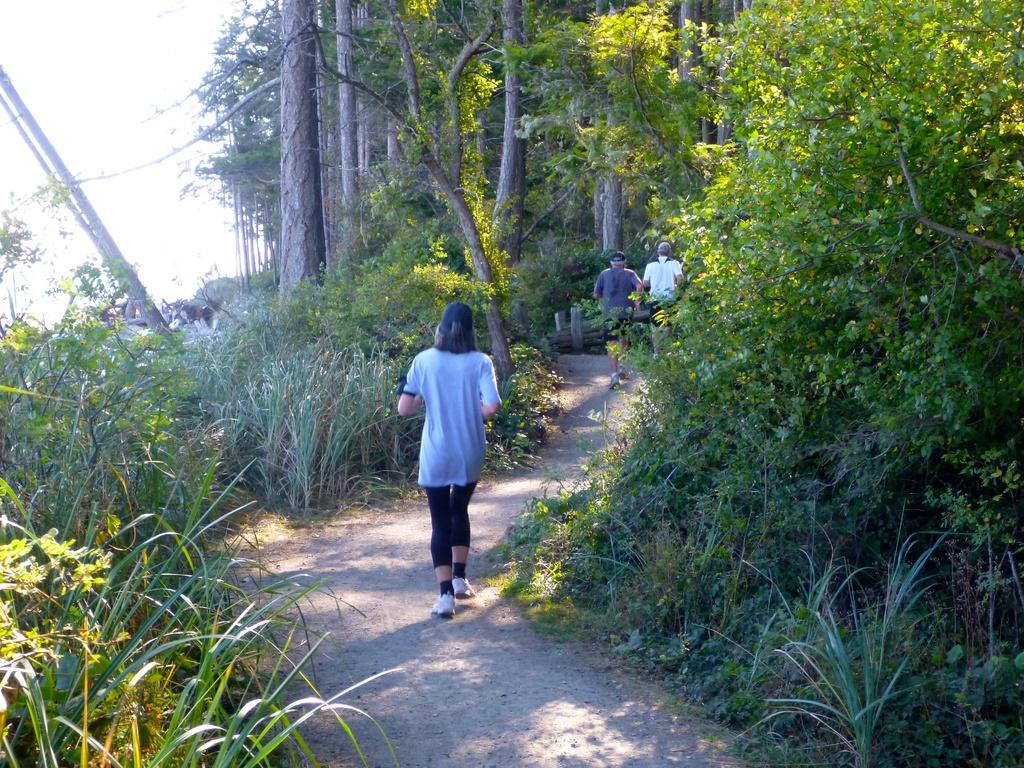What is the main feature of the image? There is a road in the image. What are the people in the image doing? Three persons are walking on the road. What type of vegetation can be seen beside the road? There is grass, plants, and trees beside the road. What part of the natural environment is visible in the image? The sky is visible in the top left of the image. What type of wood is being used to build the journey in the image? There is no journey being built in the image, nor is there any wood present. 